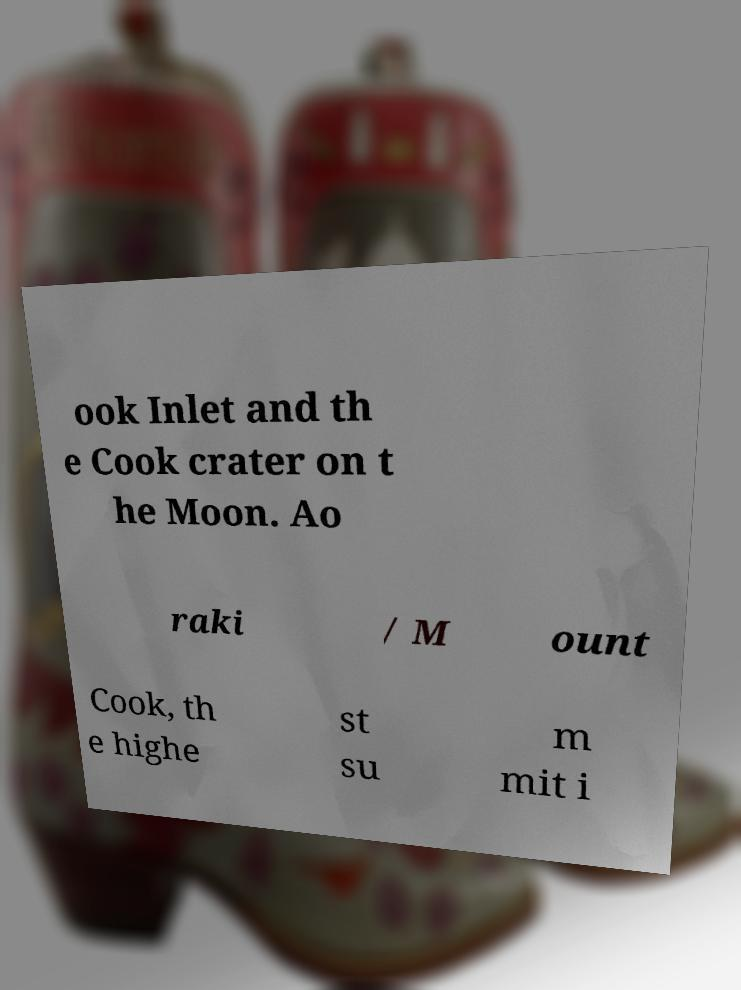There's text embedded in this image that I need extracted. Can you transcribe it verbatim? ook Inlet and th e Cook crater on t he Moon. Ao raki / M ount Cook, th e highe st su m mit i 